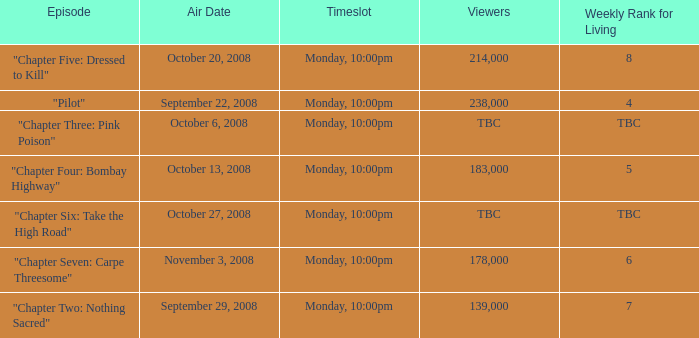What is the weekly rank for living when the air date is october 6, 2008? TBC. 